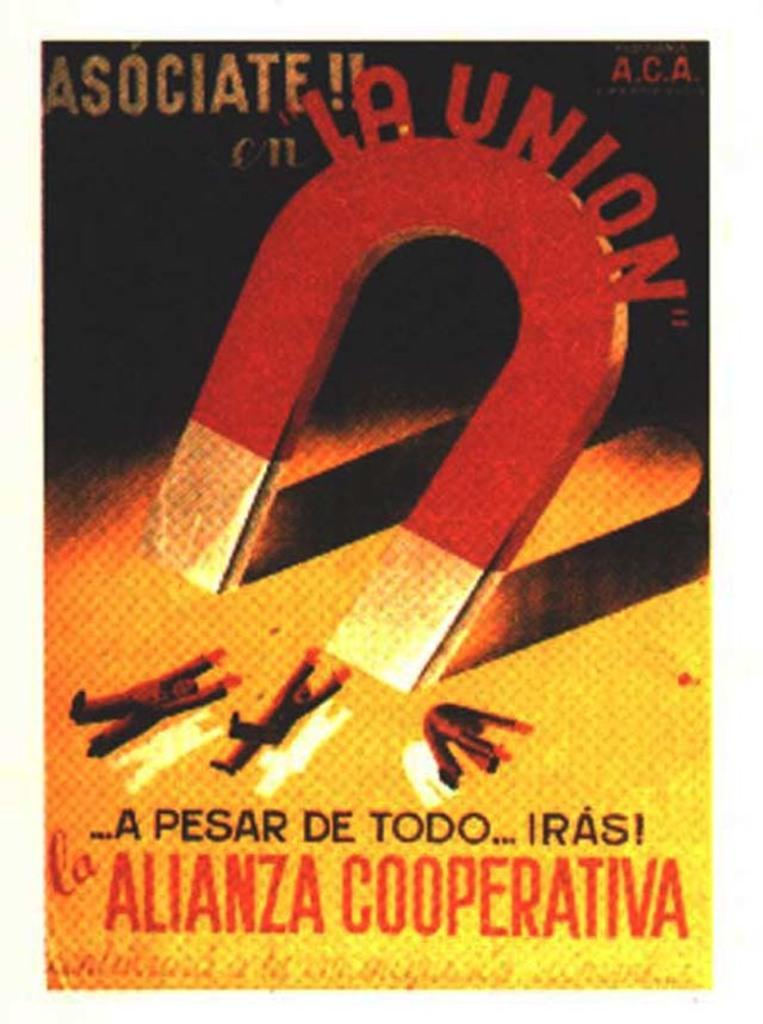<image>
Provide a brief description of the given image. An advertisement with a large magnet that says La Union on it. 